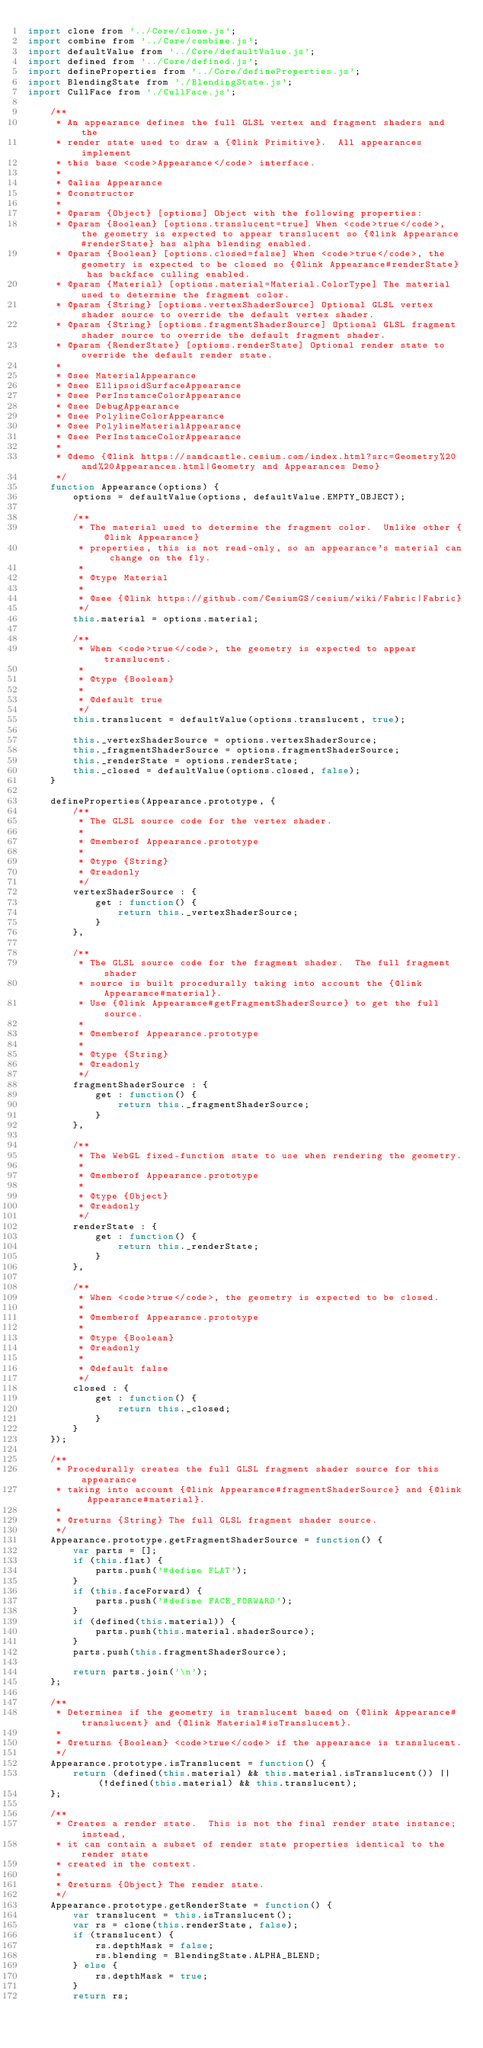Convert code to text. <code><loc_0><loc_0><loc_500><loc_500><_JavaScript_>import clone from '../Core/clone.js';
import combine from '../Core/combine.js';
import defaultValue from '../Core/defaultValue.js';
import defined from '../Core/defined.js';
import defineProperties from '../Core/defineProperties.js';
import BlendingState from './BlendingState.js';
import CullFace from './CullFace.js';

    /**
     * An appearance defines the full GLSL vertex and fragment shaders and the
     * render state used to draw a {@link Primitive}.  All appearances implement
     * this base <code>Appearance</code> interface.
     *
     * @alias Appearance
     * @constructor
     *
     * @param {Object} [options] Object with the following properties:
     * @param {Boolean} [options.translucent=true] When <code>true</code>, the geometry is expected to appear translucent so {@link Appearance#renderState} has alpha blending enabled.
     * @param {Boolean} [options.closed=false] When <code>true</code>, the geometry is expected to be closed so {@link Appearance#renderState} has backface culling enabled.
     * @param {Material} [options.material=Material.ColorType] The material used to determine the fragment color.
     * @param {String} [options.vertexShaderSource] Optional GLSL vertex shader source to override the default vertex shader.
     * @param {String} [options.fragmentShaderSource] Optional GLSL fragment shader source to override the default fragment shader.
     * @param {RenderState} [options.renderState] Optional render state to override the default render state.
     *
     * @see MaterialAppearance
     * @see EllipsoidSurfaceAppearance
     * @see PerInstanceColorAppearance
     * @see DebugAppearance
     * @see PolylineColorAppearance
     * @see PolylineMaterialAppearance
     * @see PerInstanceColorAppearance
     *
     * @demo {@link https://sandcastle.cesium.com/index.html?src=Geometry%20and%20Appearances.html|Geometry and Appearances Demo}
     */
    function Appearance(options) {
        options = defaultValue(options, defaultValue.EMPTY_OBJECT);

        /**
         * The material used to determine the fragment color.  Unlike other {@link Appearance}
         * properties, this is not read-only, so an appearance's material can change on the fly.
         *
         * @type Material
         *
         * @see {@link https://github.com/CesiumGS/cesium/wiki/Fabric|Fabric}
         */
        this.material = options.material;

        /**
         * When <code>true</code>, the geometry is expected to appear translucent.
         *
         * @type {Boolean}
         *
         * @default true
         */
        this.translucent = defaultValue(options.translucent, true);

        this._vertexShaderSource = options.vertexShaderSource;
        this._fragmentShaderSource = options.fragmentShaderSource;
        this._renderState = options.renderState;
        this._closed = defaultValue(options.closed, false);
    }

    defineProperties(Appearance.prototype, {
        /**
         * The GLSL source code for the vertex shader.
         *
         * @memberof Appearance.prototype
         *
         * @type {String}
         * @readonly
         */
        vertexShaderSource : {
            get : function() {
                return this._vertexShaderSource;
            }
        },

        /**
         * The GLSL source code for the fragment shader.  The full fragment shader
         * source is built procedurally taking into account the {@link Appearance#material}.
         * Use {@link Appearance#getFragmentShaderSource} to get the full source.
         *
         * @memberof Appearance.prototype
         *
         * @type {String}
         * @readonly
         */
        fragmentShaderSource : {
            get : function() {
                return this._fragmentShaderSource;
            }
        },

        /**
         * The WebGL fixed-function state to use when rendering the geometry.
         *
         * @memberof Appearance.prototype
         *
         * @type {Object}
         * @readonly
         */
        renderState : {
            get : function() {
                return this._renderState;
            }
        },

        /**
         * When <code>true</code>, the geometry is expected to be closed.
         *
         * @memberof Appearance.prototype
         *
         * @type {Boolean}
         * @readonly
         *
         * @default false
         */
        closed : {
            get : function() {
                return this._closed;
            }
        }
    });

    /**
     * Procedurally creates the full GLSL fragment shader source for this appearance
     * taking into account {@link Appearance#fragmentShaderSource} and {@link Appearance#material}.
     *
     * @returns {String} The full GLSL fragment shader source.
     */
    Appearance.prototype.getFragmentShaderSource = function() {
        var parts = [];
        if (this.flat) {
            parts.push('#define FLAT');
        }
        if (this.faceForward) {
            parts.push('#define FACE_FORWARD');
        }
        if (defined(this.material)) {
            parts.push(this.material.shaderSource);
        }
        parts.push(this.fragmentShaderSource);

        return parts.join('\n');
    };

    /**
     * Determines if the geometry is translucent based on {@link Appearance#translucent} and {@link Material#isTranslucent}.
     *
     * @returns {Boolean} <code>true</code> if the appearance is translucent.
     */
    Appearance.prototype.isTranslucent = function() {
        return (defined(this.material) && this.material.isTranslucent()) || (!defined(this.material) && this.translucent);
    };

    /**
     * Creates a render state.  This is not the final render state instance; instead,
     * it can contain a subset of render state properties identical to the render state
     * created in the context.
     *
     * @returns {Object} The render state.
     */
    Appearance.prototype.getRenderState = function() {
        var translucent = this.isTranslucent();
        var rs = clone(this.renderState, false);
        if (translucent) {
            rs.depthMask = false;
            rs.blending = BlendingState.ALPHA_BLEND;
        } else {
            rs.depthMask = true;
        }
        return rs;</code> 